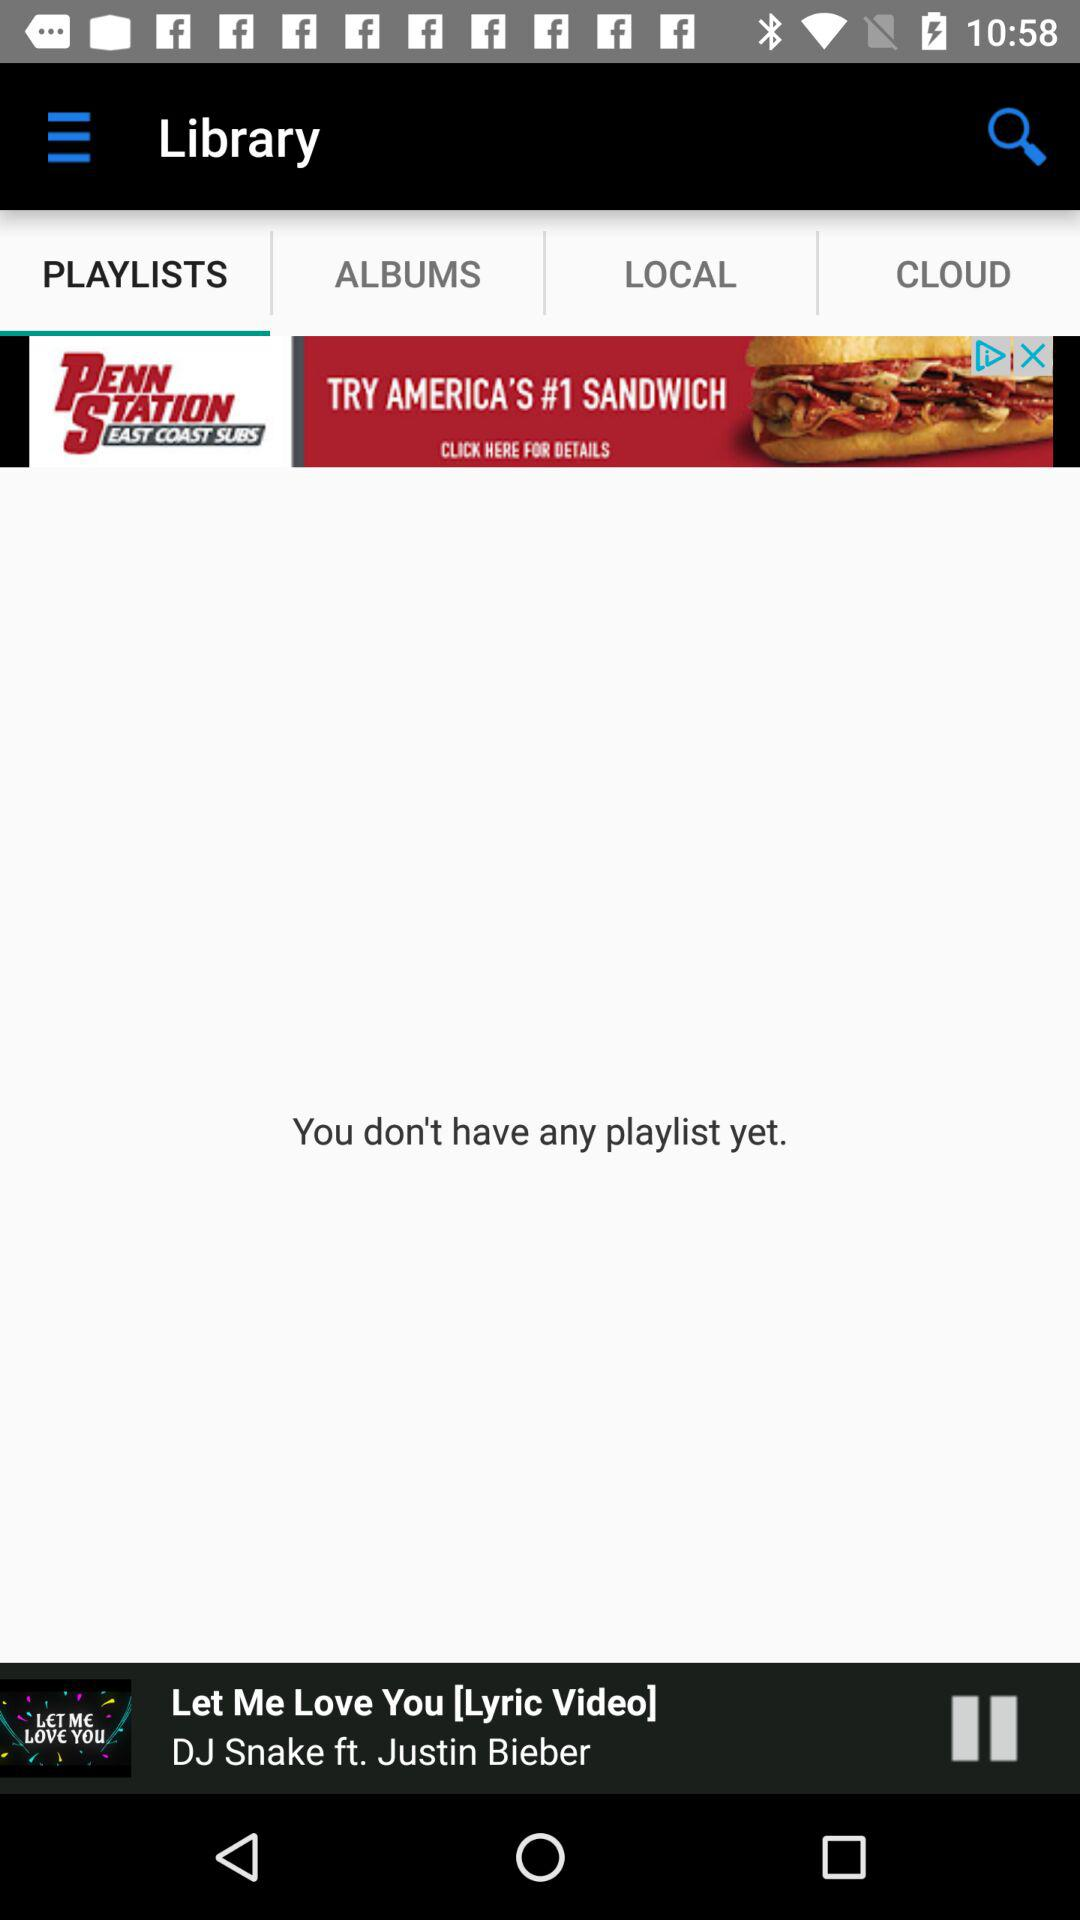What is the selected tab? The selected tab is "PLAYLISTS". 